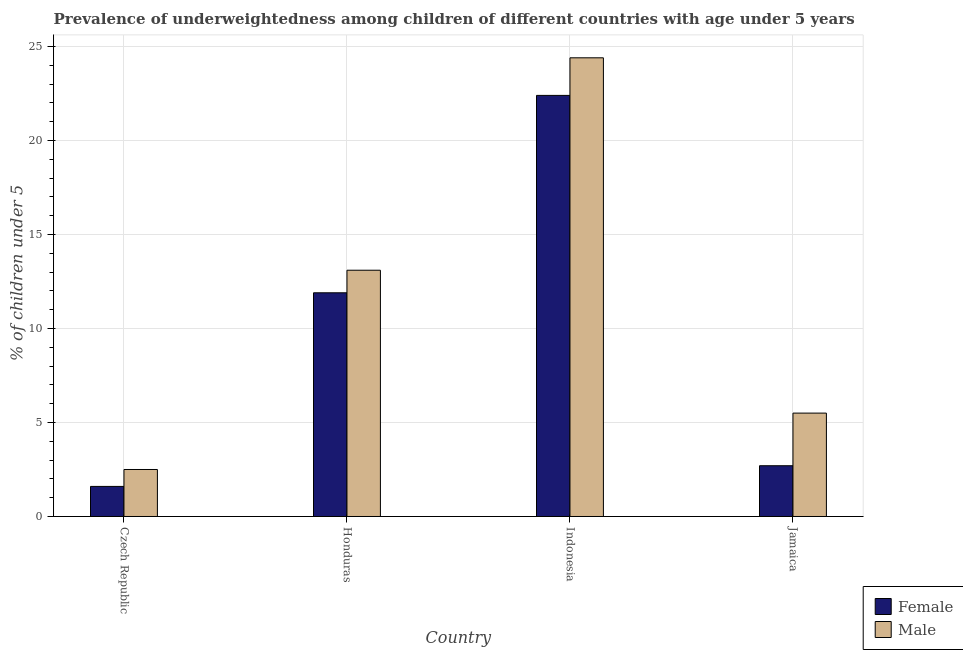How many different coloured bars are there?
Provide a short and direct response. 2. What is the label of the 3rd group of bars from the left?
Ensure brevity in your answer.  Indonesia. In how many cases, is the number of bars for a given country not equal to the number of legend labels?
Keep it short and to the point. 0. What is the percentage of underweighted female children in Indonesia?
Offer a terse response. 22.4. Across all countries, what is the maximum percentage of underweighted male children?
Offer a terse response. 24.4. Across all countries, what is the minimum percentage of underweighted female children?
Keep it short and to the point. 1.6. In which country was the percentage of underweighted female children minimum?
Your answer should be very brief. Czech Republic. What is the total percentage of underweighted male children in the graph?
Provide a succinct answer. 45.5. What is the difference between the percentage of underweighted female children in Czech Republic and that in Jamaica?
Make the answer very short. -1.1. What is the difference between the percentage of underweighted female children in Czech Republic and the percentage of underweighted male children in Jamaica?
Ensure brevity in your answer.  -3.9. What is the average percentage of underweighted female children per country?
Give a very brief answer. 9.65. What is the ratio of the percentage of underweighted female children in Honduras to that in Indonesia?
Provide a short and direct response. 0.53. Is the difference between the percentage of underweighted male children in Czech Republic and Jamaica greater than the difference between the percentage of underweighted female children in Czech Republic and Jamaica?
Provide a short and direct response. No. What is the difference between the highest and the second highest percentage of underweighted female children?
Your response must be concise. 10.5. What is the difference between the highest and the lowest percentage of underweighted female children?
Offer a very short reply. 20.8. In how many countries, is the percentage of underweighted male children greater than the average percentage of underweighted male children taken over all countries?
Your answer should be compact. 2. Is the sum of the percentage of underweighted female children in Indonesia and Jamaica greater than the maximum percentage of underweighted male children across all countries?
Provide a short and direct response. Yes. What does the 1st bar from the left in Honduras represents?
Ensure brevity in your answer.  Female. Are all the bars in the graph horizontal?
Your response must be concise. No. How many countries are there in the graph?
Make the answer very short. 4. What is the difference between two consecutive major ticks on the Y-axis?
Offer a terse response. 5. Does the graph contain any zero values?
Your response must be concise. No. How many legend labels are there?
Offer a very short reply. 2. What is the title of the graph?
Your answer should be very brief. Prevalence of underweightedness among children of different countries with age under 5 years. What is the label or title of the X-axis?
Your answer should be very brief. Country. What is the label or title of the Y-axis?
Your answer should be very brief.  % of children under 5. What is the  % of children under 5 in Female in Czech Republic?
Offer a very short reply. 1.6. What is the  % of children under 5 in Female in Honduras?
Keep it short and to the point. 11.9. What is the  % of children under 5 of Male in Honduras?
Provide a short and direct response. 13.1. What is the  % of children under 5 of Female in Indonesia?
Give a very brief answer. 22.4. What is the  % of children under 5 in Male in Indonesia?
Offer a terse response. 24.4. What is the  % of children under 5 of Female in Jamaica?
Offer a terse response. 2.7. What is the  % of children under 5 of Male in Jamaica?
Make the answer very short. 5.5. Across all countries, what is the maximum  % of children under 5 in Female?
Ensure brevity in your answer.  22.4. Across all countries, what is the maximum  % of children under 5 of Male?
Give a very brief answer. 24.4. Across all countries, what is the minimum  % of children under 5 of Female?
Make the answer very short. 1.6. What is the total  % of children under 5 of Female in the graph?
Keep it short and to the point. 38.6. What is the total  % of children under 5 in Male in the graph?
Your answer should be very brief. 45.5. What is the difference between the  % of children under 5 in Female in Czech Republic and that in Honduras?
Provide a succinct answer. -10.3. What is the difference between the  % of children under 5 in Female in Czech Republic and that in Indonesia?
Make the answer very short. -20.8. What is the difference between the  % of children under 5 in Male in Czech Republic and that in Indonesia?
Your response must be concise. -21.9. What is the difference between the  % of children under 5 in Male in Czech Republic and that in Jamaica?
Make the answer very short. -3. What is the difference between the  % of children under 5 in Female in Honduras and that in Indonesia?
Make the answer very short. -10.5. What is the difference between the  % of children under 5 in Male in Honduras and that in Indonesia?
Your answer should be compact. -11.3. What is the difference between the  % of children under 5 in Female in Honduras and that in Jamaica?
Offer a very short reply. 9.2. What is the difference between the  % of children under 5 of Male in Honduras and that in Jamaica?
Provide a succinct answer. 7.6. What is the difference between the  % of children under 5 of Male in Indonesia and that in Jamaica?
Your answer should be very brief. 18.9. What is the difference between the  % of children under 5 in Female in Czech Republic and the  % of children under 5 in Male in Honduras?
Make the answer very short. -11.5. What is the difference between the  % of children under 5 of Female in Czech Republic and the  % of children under 5 of Male in Indonesia?
Your answer should be compact. -22.8. What is the difference between the  % of children under 5 of Female in Czech Republic and the  % of children under 5 of Male in Jamaica?
Provide a short and direct response. -3.9. What is the difference between the  % of children under 5 in Female in Honduras and the  % of children under 5 in Male in Indonesia?
Your answer should be compact. -12.5. What is the difference between the  % of children under 5 of Female in Honduras and the  % of children under 5 of Male in Jamaica?
Keep it short and to the point. 6.4. What is the difference between the  % of children under 5 in Female in Indonesia and the  % of children under 5 in Male in Jamaica?
Give a very brief answer. 16.9. What is the average  % of children under 5 of Female per country?
Provide a short and direct response. 9.65. What is the average  % of children under 5 in Male per country?
Keep it short and to the point. 11.38. What is the difference between the  % of children under 5 in Female and  % of children under 5 in Male in Honduras?
Ensure brevity in your answer.  -1.2. What is the difference between the  % of children under 5 of Female and  % of children under 5 of Male in Indonesia?
Give a very brief answer. -2. What is the ratio of the  % of children under 5 in Female in Czech Republic to that in Honduras?
Ensure brevity in your answer.  0.13. What is the ratio of the  % of children under 5 of Male in Czech Republic to that in Honduras?
Your response must be concise. 0.19. What is the ratio of the  % of children under 5 of Female in Czech Republic to that in Indonesia?
Offer a very short reply. 0.07. What is the ratio of the  % of children under 5 in Male in Czech Republic to that in Indonesia?
Your answer should be very brief. 0.1. What is the ratio of the  % of children under 5 in Female in Czech Republic to that in Jamaica?
Ensure brevity in your answer.  0.59. What is the ratio of the  % of children under 5 in Male in Czech Republic to that in Jamaica?
Ensure brevity in your answer.  0.45. What is the ratio of the  % of children under 5 of Female in Honduras to that in Indonesia?
Offer a very short reply. 0.53. What is the ratio of the  % of children under 5 of Male in Honduras to that in Indonesia?
Ensure brevity in your answer.  0.54. What is the ratio of the  % of children under 5 of Female in Honduras to that in Jamaica?
Offer a terse response. 4.41. What is the ratio of the  % of children under 5 in Male in Honduras to that in Jamaica?
Your response must be concise. 2.38. What is the ratio of the  % of children under 5 of Female in Indonesia to that in Jamaica?
Ensure brevity in your answer.  8.3. What is the ratio of the  % of children under 5 in Male in Indonesia to that in Jamaica?
Your answer should be compact. 4.44. What is the difference between the highest and the lowest  % of children under 5 of Female?
Your response must be concise. 20.8. What is the difference between the highest and the lowest  % of children under 5 in Male?
Keep it short and to the point. 21.9. 